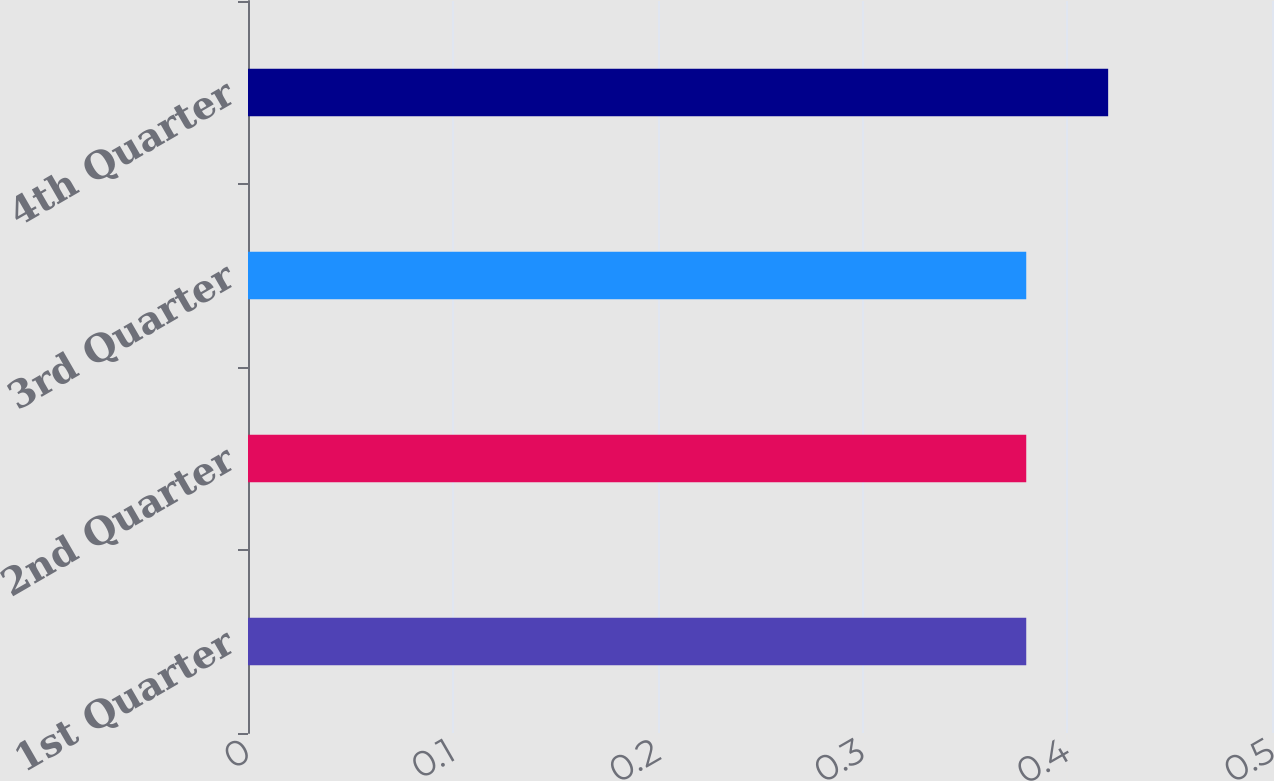Convert chart to OTSL. <chart><loc_0><loc_0><loc_500><loc_500><bar_chart><fcel>1st Quarter<fcel>2nd Quarter<fcel>3rd Quarter<fcel>4th Quarter<nl><fcel>0.38<fcel>0.38<fcel>0.38<fcel>0.42<nl></chart> 